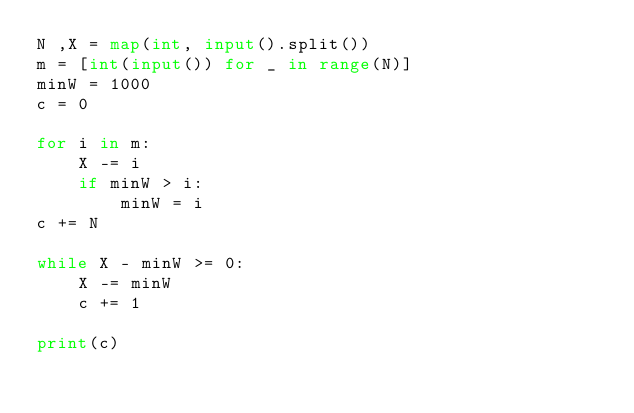Convert code to text. <code><loc_0><loc_0><loc_500><loc_500><_Python_>N ,X = map(int, input().split())
m = [int(input()) for _ in range(N)]
minW = 1000
c = 0

for i in m:
    X -= i
    if minW > i:
        minW = i
c += N

while X - minW >= 0:
    X -= minW
    c += 1

print(c)</code> 